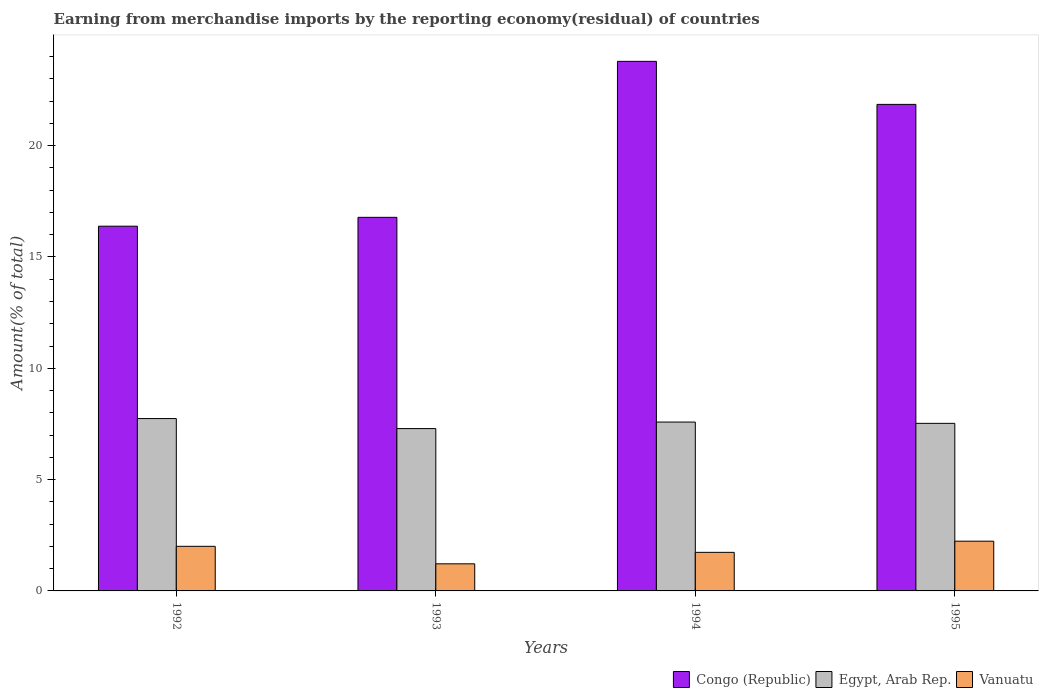How many groups of bars are there?
Make the answer very short. 4. Are the number of bars on each tick of the X-axis equal?
Offer a very short reply. Yes. How many bars are there on the 2nd tick from the left?
Give a very brief answer. 3. How many bars are there on the 4th tick from the right?
Make the answer very short. 3. What is the label of the 3rd group of bars from the left?
Offer a terse response. 1994. What is the percentage of amount earned from merchandise imports in Congo (Republic) in 1995?
Give a very brief answer. 21.85. Across all years, what is the maximum percentage of amount earned from merchandise imports in Egypt, Arab Rep.?
Offer a terse response. 7.74. Across all years, what is the minimum percentage of amount earned from merchandise imports in Egypt, Arab Rep.?
Offer a terse response. 7.29. In which year was the percentage of amount earned from merchandise imports in Vanuatu maximum?
Give a very brief answer. 1995. In which year was the percentage of amount earned from merchandise imports in Egypt, Arab Rep. minimum?
Provide a succinct answer. 1993. What is the total percentage of amount earned from merchandise imports in Vanuatu in the graph?
Ensure brevity in your answer.  7.19. What is the difference between the percentage of amount earned from merchandise imports in Congo (Republic) in 1994 and that in 1995?
Make the answer very short. 1.93. What is the difference between the percentage of amount earned from merchandise imports in Egypt, Arab Rep. in 1992 and the percentage of amount earned from merchandise imports in Vanuatu in 1993?
Keep it short and to the point. 6.52. What is the average percentage of amount earned from merchandise imports in Vanuatu per year?
Your answer should be very brief. 1.8. In the year 1994, what is the difference between the percentage of amount earned from merchandise imports in Egypt, Arab Rep. and percentage of amount earned from merchandise imports in Congo (Republic)?
Ensure brevity in your answer.  -16.2. What is the ratio of the percentage of amount earned from merchandise imports in Congo (Republic) in 1992 to that in 1995?
Provide a succinct answer. 0.75. What is the difference between the highest and the second highest percentage of amount earned from merchandise imports in Congo (Republic)?
Provide a succinct answer. 1.93. What is the difference between the highest and the lowest percentage of amount earned from merchandise imports in Vanuatu?
Make the answer very short. 1.02. In how many years, is the percentage of amount earned from merchandise imports in Congo (Republic) greater than the average percentage of amount earned from merchandise imports in Congo (Republic) taken over all years?
Ensure brevity in your answer.  2. Is the sum of the percentage of amount earned from merchandise imports in Vanuatu in 1993 and 1995 greater than the maximum percentage of amount earned from merchandise imports in Egypt, Arab Rep. across all years?
Offer a very short reply. No. What does the 2nd bar from the left in 1995 represents?
Your response must be concise. Egypt, Arab Rep. What does the 3rd bar from the right in 1992 represents?
Make the answer very short. Congo (Republic). How many bars are there?
Provide a short and direct response. 12. Are all the bars in the graph horizontal?
Your response must be concise. No. How many years are there in the graph?
Give a very brief answer. 4. Are the values on the major ticks of Y-axis written in scientific E-notation?
Provide a succinct answer. No. What is the title of the graph?
Ensure brevity in your answer.  Earning from merchandise imports by the reporting economy(residual) of countries. Does "Philippines" appear as one of the legend labels in the graph?
Provide a succinct answer. No. What is the label or title of the X-axis?
Ensure brevity in your answer.  Years. What is the label or title of the Y-axis?
Your answer should be compact. Amount(% of total). What is the Amount(% of total) of Congo (Republic) in 1992?
Provide a short and direct response. 16.38. What is the Amount(% of total) of Egypt, Arab Rep. in 1992?
Provide a succinct answer. 7.74. What is the Amount(% of total) of Vanuatu in 1992?
Ensure brevity in your answer.  2. What is the Amount(% of total) in Congo (Republic) in 1993?
Your answer should be compact. 16.78. What is the Amount(% of total) of Egypt, Arab Rep. in 1993?
Provide a short and direct response. 7.29. What is the Amount(% of total) in Vanuatu in 1993?
Your response must be concise. 1.22. What is the Amount(% of total) in Congo (Republic) in 1994?
Your response must be concise. 23.78. What is the Amount(% of total) in Egypt, Arab Rep. in 1994?
Your response must be concise. 7.58. What is the Amount(% of total) in Vanuatu in 1994?
Provide a succinct answer. 1.73. What is the Amount(% of total) of Congo (Republic) in 1995?
Keep it short and to the point. 21.85. What is the Amount(% of total) in Egypt, Arab Rep. in 1995?
Offer a terse response. 7.53. What is the Amount(% of total) in Vanuatu in 1995?
Offer a very short reply. 2.23. Across all years, what is the maximum Amount(% of total) in Congo (Republic)?
Provide a succinct answer. 23.78. Across all years, what is the maximum Amount(% of total) of Egypt, Arab Rep.?
Your response must be concise. 7.74. Across all years, what is the maximum Amount(% of total) in Vanuatu?
Make the answer very short. 2.23. Across all years, what is the minimum Amount(% of total) in Congo (Republic)?
Offer a very short reply. 16.38. Across all years, what is the minimum Amount(% of total) of Egypt, Arab Rep.?
Make the answer very short. 7.29. Across all years, what is the minimum Amount(% of total) in Vanuatu?
Provide a succinct answer. 1.22. What is the total Amount(% of total) in Congo (Republic) in the graph?
Keep it short and to the point. 78.8. What is the total Amount(% of total) of Egypt, Arab Rep. in the graph?
Your answer should be compact. 30.14. What is the total Amount(% of total) of Vanuatu in the graph?
Keep it short and to the point. 7.19. What is the difference between the Amount(% of total) of Congo (Republic) in 1992 and that in 1993?
Your answer should be compact. -0.4. What is the difference between the Amount(% of total) in Egypt, Arab Rep. in 1992 and that in 1993?
Ensure brevity in your answer.  0.45. What is the difference between the Amount(% of total) in Vanuatu in 1992 and that in 1993?
Offer a very short reply. 0.79. What is the difference between the Amount(% of total) of Congo (Republic) in 1992 and that in 1994?
Make the answer very short. -7.4. What is the difference between the Amount(% of total) in Egypt, Arab Rep. in 1992 and that in 1994?
Provide a short and direct response. 0.16. What is the difference between the Amount(% of total) of Vanuatu in 1992 and that in 1994?
Offer a very short reply. 0.27. What is the difference between the Amount(% of total) of Congo (Republic) in 1992 and that in 1995?
Offer a terse response. -5.47. What is the difference between the Amount(% of total) in Egypt, Arab Rep. in 1992 and that in 1995?
Offer a terse response. 0.22. What is the difference between the Amount(% of total) of Vanuatu in 1992 and that in 1995?
Give a very brief answer. -0.23. What is the difference between the Amount(% of total) of Congo (Republic) in 1993 and that in 1994?
Make the answer very short. -7.01. What is the difference between the Amount(% of total) of Egypt, Arab Rep. in 1993 and that in 1994?
Give a very brief answer. -0.29. What is the difference between the Amount(% of total) of Vanuatu in 1993 and that in 1994?
Offer a terse response. -0.51. What is the difference between the Amount(% of total) in Congo (Republic) in 1993 and that in 1995?
Your answer should be very brief. -5.07. What is the difference between the Amount(% of total) in Egypt, Arab Rep. in 1993 and that in 1995?
Your answer should be very brief. -0.23. What is the difference between the Amount(% of total) of Vanuatu in 1993 and that in 1995?
Give a very brief answer. -1.02. What is the difference between the Amount(% of total) in Congo (Republic) in 1994 and that in 1995?
Your answer should be very brief. 1.93. What is the difference between the Amount(% of total) in Egypt, Arab Rep. in 1994 and that in 1995?
Offer a very short reply. 0.06. What is the difference between the Amount(% of total) of Vanuatu in 1994 and that in 1995?
Offer a terse response. -0.5. What is the difference between the Amount(% of total) of Congo (Republic) in 1992 and the Amount(% of total) of Egypt, Arab Rep. in 1993?
Offer a terse response. 9.09. What is the difference between the Amount(% of total) in Congo (Republic) in 1992 and the Amount(% of total) in Vanuatu in 1993?
Your answer should be very brief. 15.16. What is the difference between the Amount(% of total) of Egypt, Arab Rep. in 1992 and the Amount(% of total) of Vanuatu in 1993?
Make the answer very short. 6.52. What is the difference between the Amount(% of total) in Congo (Republic) in 1992 and the Amount(% of total) in Egypt, Arab Rep. in 1994?
Your response must be concise. 8.8. What is the difference between the Amount(% of total) of Congo (Republic) in 1992 and the Amount(% of total) of Vanuatu in 1994?
Ensure brevity in your answer.  14.65. What is the difference between the Amount(% of total) of Egypt, Arab Rep. in 1992 and the Amount(% of total) of Vanuatu in 1994?
Provide a succinct answer. 6.01. What is the difference between the Amount(% of total) in Congo (Republic) in 1992 and the Amount(% of total) in Egypt, Arab Rep. in 1995?
Keep it short and to the point. 8.86. What is the difference between the Amount(% of total) in Congo (Republic) in 1992 and the Amount(% of total) in Vanuatu in 1995?
Ensure brevity in your answer.  14.15. What is the difference between the Amount(% of total) of Egypt, Arab Rep. in 1992 and the Amount(% of total) of Vanuatu in 1995?
Provide a short and direct response. 5.51. What is the difference between the Amount(% of total) in Congo (Republic) in 1993 and the Amount(% of total) in Egypt, Arab Rep. in 1994?
Make the answer very short. 9.19. What is the difference between the Amount(% of total) in Congo (Republic) in 1993 and the Amount(% of total) in Vanuatu in 1994?
Your answer should be very brief. 15.05. What is the difference between the Amount(% of total) in Egypt, Arab Rep. in 1993 and the Amount(% of total) in Vanuatu in 1994?
Keep it short and to the point. 5.56. What is the difference between the Amount(% of total) in Congo (Republic) in 1993 and the Amount(% of total) in Egypt, Arab Rep. in 1995?
Your answer should be compact. 9.25. What is the difference between the Amount(% of total) in Congo (Republic) in 1993 and the Amount(% of total) in Vanuatu in 1995?
Provide a succinct answer. 14.54. What is the difference between the Amount(% of total) of Egypt, Arab Rep. in 1993 and the Amount(% of total) of Vanuatu in 1995?
Your answer should be compact. 5.06. What is the difference between the Amount(% of total) in Congo (Republic) in 1994 and the Amount(% of total) in Egypt, Arab Rep. in 1995?
Give a very brief answer. 16.26. What is the difference between the Amount(% of total) in Congo (Republic) in 1994 and the Amount(% of total) in Vanuatu in 1995?
Your response must be concise. 21.55. What is the difference between the Amount(% of total) in Egypt, Arab Rep. in 1994 and the Amount(% of total) in Vanuatu in 1995?
Give a very brief answer. 5.35. What is the average Amount(% of total) in Congo (Republic) per year?
Provide a succinct answer. 19.7. What is the average Amount(% of total) of Egypt, Arab Rep. per year?
Offer a terse response. 7.54. What is the average Amount(% of total) of Vanuatu per year?
Keep it short and to the point. 1.8. In the year 1992, what is the difference between the Amount(% of total) in Congo (Republic) and Amount(% of total) in Egypt, Arab Rep.?
Offer a terse response. 8.64. In the year 1992, what is the difference between the Amount(% of total) in Congo (Republic) and Amount(% of total) in Vanuatu?
Your answer should be compact. 14.38. In the year 1992, what is the difference between the Amount(% of total) in Egypt, Arab Rep. and Amount(% of total) in Vanuatu?
Give a very brief answer. 5.74. In the year 1993, what is the difference between the Amount(% of total) of Congo (Republic) and Amount(% of total) of Egypt, Arab Rep.?
Give a very brief answer. 9.49. In the year 1993, what is the difference between the Amount(% of total) in Congo (Republic) and Amount(% of total) in Vanuatu?
Offer a very short reply. 15.56. In the year 1993, what is the difference between the Amount(% of total) in Egypt, Arab Rep. and Amount(% of total) in Vanuatu?
Your answer should be very brief. 6.07. In the year 1994, what is the difference between the Amount(% of total) of Congo (Republic) and Amount(% of total) of Egypt, Arab Rep.?
Keep it short and to the point. 16.2. In the year 1994, what is the difference between the Amount(% of total) in Congo (Republic) and Amount(% of total) in Vanuatu?
Your answer should be very brief. 22.05. In the year 1994, what is the difference between the Amount(% of total) of Egypt, Arab Rep. and Amount(% of total) of Vanuatu?
Offer a terse response. 5.85. In the year 1995, what is the difference between the Amount(% of total) in Congo (Republic) and Amount(% of total) in Egypt, Arab Rep.?
Make the answer very short. 14.33. In the year 1995, what is the difference between the Amount(% of total) of Congo (Republic) and Amount(% of total) of Vanuatu?
Give a very brief answer. 19.62. In the year 1995, what is the difference between the Amount(% of total) of Egypt, Arab Rep. and Amount(% of total) of Vanuatu?
Offer a terse response. 5.29. What is the ratio of the Amount(% of total) of Congo (Republic) in 1992 to that in 1993?
Your answer should be very brief. 0.98. What is the ratio of the Amount(% of total) in Egypt, Arab Rep. in 1992 to that in 1993?
Provide a succinct answer. 1.06. What is the ratio of the Amount(% of total) of Vanuatu in 1992 to that in 1993?
Provide a succinct answer. 1.65. What is the ratio of the Amount(% of total) of Congo (Republic) in 1992 to that in 1994?
Make the answer very short. 0.69. What is the ratio of the Amount(% of total) in Egypt, Arab Rep. in 1992 to that in 1994?
Ensure brevity in your answer.  1.02. What is the ratio of the Amount(% of total) in Vanuatu in 1992 to that in 1994?
Give a very brief answer. 1.16. What is the ratio of the Amount(% of total) in Congo (Republic) in 1992 to that in 1995?
Give a very brief answer. 0.75. What is the ratio of the Amount(% of total) of Egypt, Arab Rep. in 1992 to that in 1995?
Give a very brief answer. 1.03. What is the ratio of the Amount(% of total) in Vanuatu in 1992 to that in 1995?
Make the answer very short. 0.9. What is the ratio of the Amount(% of total) in Congo (Republic) in 1993 to that in 1994?
Your answer should be compact. 0.71. What is the ratio of the Amount(% of total) in Egypt, Arab Rep. in 1993 to that in 1994?
Your response must be concise. 0.96. What is the ratio of the Amount(% of total) of Vanuatu in 1993 to that in 1994?
Give a very brief answer. 0.7. What is the ratio of the Amount(% of total) in Congo (Republic) in 1993 to that in 1995?
Give a very brief answer. 0.77. What is the ratio of the Amount(% of total) of Egypt, Arab Rep. in 1993 to that in 1995?
Your answer should be very brief. 0.97. What is the ratio of the Amount(% of total) in Vanuatu in 1993 to that in 1995?
Keep it short and to the point. 0.55. What is the ratio of the Amount(% of total) of Congo (Republic) in 1994 to that in 1995?
Your answer should be compact. 1.09. What is the ratio of the Amount(% of total) in Egypt, Arab Rep. in 1994 to that in 1995?
Your answer should be compact. 1.01. What is the ratio of the Amount(% of total) of Vanuatu in 1994 to that in 1995?
Give a very brief answer. 0.78. What is the difference between the highest and the second highest Amount(% of total) in Congo (Republic)?
Offer a very short reply. 1.93. What is the difference between the highest and the second highest Amount(% of total) of Egypt, Arab Rep.?
Ensure brevity in your answer.  0.16. What is the difference between the highest and the second highest Amount(% of total) of Vanuatu?
Offer a very short reply. 0.23. What is the difference between the highest and the lowest Amount(% of total) in Congo (Republic)?
Provide a short and direct response. 7.4. What is the difference between the highest and the lowest Amount(% of total) of Egypt, Arab Rep.?
Provide a succinct answer. 0.45. What is the difference between the highest and the lowest Amount(% of total) of Vanuatu?
Provide a succinct answer. 1.02. 